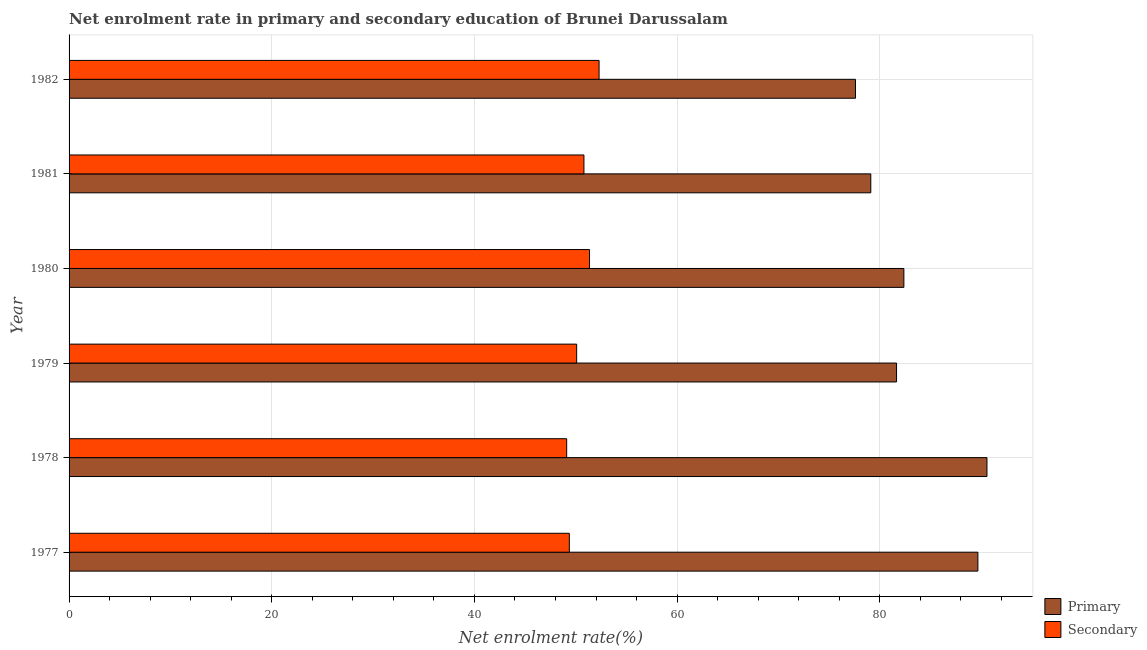How many different coloured bars are there?
Give a very brief answer. 2. How many bars are there on the 2nd tick from the top?
Offer a very short reply. 2. What is the enrollment rate in primary education in 1981?
Your answer should be very brief. 79.11. Across all years, what is the maximum enrollment rate in secondary education?
Your answer should be compact. 52.3. Across all years, what is the minimum enrollment rate in primary education?
Ensure brevity in your answer.  77.6. In which year was the enrollment rate in secondary education maximum?
Offer a very short reply. 1982. What is the total enrollment rate in secondary education in the graph?
Keep it short and to the point. 303.01. What is the difference between the enrollment rate in secondary education in 1979 and that in 1980?
Offer a terse response. -1.27. What is the difference between the enrollment rate in secondary education in 1982 and the enrollment rate in primary education in 1981?
Give a very brief answer. -26.81. What is the average enrollment rate in primary education per year?
Your answer should be very brief. 83.5. In the year 1979, what is the difference between the enrollment rate in secondary education and enrollment rate in primary education?
Give a very brief answer. -31.57. In how many years, is the enrollment rate in primary education greater than 76 %?
Offer a terse response. 6. What is the ratio of the enrollment rate in primary education in 1978 to that in 1982?
Your answer should be compact. 1.17. Is the enrollment rate in secondary education in 1977 less than that in 1981?
Make the answer very short. Yes. What is the difference between the highest and the second highest enrollment rate in primary education?
Offer a terse response. 0.9. What is the difference between the highest and the lowest enrollment rate in primary education?
Offer a terse response. 12.97. In how many years, is the enrollment rate in secondary education greater than the average enrollment rate in secondary education taken over all years?
Provide a short and direct response. 3. Is the sum of the enrollment rate in primary education in 1977 and 1980 greater than the maximum enrollment rate in secondary education across all years?
Keep it short and to the point. Yes. What does the 1st bar from the top in 1981 represents?
Keep it short and to the point. Secondary. What does the 2nd bar from the bottom in 1981 represents?
Keep it short and to the point. Secondary. How many years are there in the graph?
Ensure brevity in your answer.  6. What is the difference between two consecutive major ticks on the X-axis?
Provide a short and direct response. 20. Are the values on the major ticks of X-axis written in scientific E-notation?
Offer a very short reply. No. Does the graph contain any zero values?
Your answer should be compact. No. Where does the legend appear in the graph?
Provide a short and direct response. Bottom right. How many legend labels are there?
Provide a succinct answer. 2. How are the legend labels stacked?
Provide a short and direct response. Vertical. What is the title of the graph?
Provide a succinct answer. Net enrolment rate in primary and secondary education of Brunei Darussalam. Does "RDB concessional" appear as one of the legend labels in the graph?
Provide a short and direct response. No. What is the label or title of the X-axis?
Ensure brevity in your answer.  Net enrolment rate(%). What is the Net enrolment rate(%) in Primary in 1977?
Make the answer very short. 89.68. What is the Net enrolment rate(%) in Secondary in 1977?
Keep it short and to the point. 49.36. What is the Net enrolment rate(%) in Primary in 1978?
Keep it short and to the point. 90.57. What is the Net enrolment rate(%) of Secondary in 1978?
Provide a short and direct response. 49.1. What is the Net enrolment rate(%) of Primary in 1979?
Give a very brief answer. 81.65. What is the Net enrolment rate(%) of Secondary in 1979?
Keep it short and to the point. 50.09. What is the Net enrolment rate(%) of Primary in 1980?
Keep it short and to the point. 82.38. What is the Net enrolment rate(%) of Secondary in 1980?
Keep it short and to the point. 51.36. What is the Net enrolment rate(%) of Primary in 1981?
Provide a short and direct response. 79.11. What is the Net enrolment rate(%) in Secondary in 1981?
Give a very brief answer. 50.8. What is the Net enrolment rate(%) of Primary in 1982?
Ensure brevity in your answer.  77.6. What is the Net enrolment rate(%) of Secondary in 1982?
Your response must be concise. 52.3. Across all years, what is the maximum Net enrolment rate(%) in Primary?
Ensure brevity in your answer.  90.57. Across all years, what is the maximum Net enrolment rate(%) of Secondary?
Give a very brief answer. 52.3. Across all years, what is the minimum Net enrolment rate(%) in Primary?
Offer a terse response. 77.6. Across all years, what is the minimum Net enrolment rate(%) in Secondary?
Offer a very short reply. 49.1. What is the total Net enrolment rate(%) of Primary in the graph?
Provide a succinct answer. 500.99. What is the total Net enrolment rate(%) in Secondary in the graph?
Your response must be concise. 303.01. What is the difference between the Net enrolment rate(%) of Primary in 1977 and that in 1978?
Make the answer very short. -0.9. What is the difference between the Net enrolment rate(%) in Secondary in 1977 and that in 1978?
Offer a terse response. 0.26. What is the difference between the Net enrolment rate(%) in Primary in 1977 and that in 1979?
Provide a succinct answer. 8.03. What is the difference between the Net enrolment rate(%) in Secondary in 1977 and that in 1979?
Offer a terse response. -0.72. What is the difference between the Net enrolment rate(%) in Primary in 1977 and that in 1980?
Give a very brief answer. 7.3. What is the difference between the Net enrolment rate(%) in Secondary in 1977 and that in 1980?
Your response must be concise. -1.99. What is the difference between the Net enrolment rate(%) of Primary in 1977 and that in 1981?
Make the answer very short. 10.57. What is the difference between the Net enrolment rate(%) of Secondary in 1977 and that in 1981?
Ensure brevity in your answer.  -1.44. What is the difference between the Net enrolment rate(%) of Primary in 1977 and that in 1982?
Make the answer very short. 12.08. What is the difference between the Net enrolment rate(%) of Secondary in 1977 and that in 1982?
Offer a terse response. -2.94. What is the difference between the Net enrolment rate(%) in Primary in 1978 and that in 1979?
Make the answer very short. 8.92. What is the difference between the Net enrolment rate(%) in Secondary in 1978 and that in 1979?
Keep it short and to the point. -0.98. What is the difference between the Net enrolment rate(%) of Primary in 1978 and that in 1980?
Make the answer very short. 8.2. What is the difference between the Net enrolment rate(%) of Secondary in 1978 and that in 1980?
Give a very brief answer. -2.25. What is the difference between the Net enrolment rate(%) of Primary in 1978 and that in 1981?
Provide a succinct answer. 11.46. What is the difference between the Net enrolment rate(%) in Secondary in 1978 and that in 1981?
Give a very brief answer. -1.7. What is the difference between the Net enrolment rate(%) of Primary in 1978 and that in 1982?
Your answer should be compact. 12.97. What is the difference between the Net enrolment rate(%) in Secondary in 1978 and that in 1982?
Offer a terse response. -3.2. What is the difference between the Net enrolment rate(%) of Primary in 1979 and that in 1980?
Your answer should be very brief. -0.72. What is the difference between the Net enrolment rate(%) of Secondary in 1979 and that in 1980?
Give a very brief answer. -1.27. What is the difference between the Net enrolment rate(%) of Primary in 1979 and that in 1981?
Ensure brevity in your answer.  2.54. What is the difference between the Net enrolment rate(%) in Secondary in 1979 and that in 1981?
Provide a succinct answer. -0.72. What is the difference between the Net enrolment rate(%) of Primary in 1979 and that in 1982?
Your response must be concise. 4.05. What is the difference between the Net enrolment rate(%) of Secondary in 1979 and that in 1982?
Provide a short and direct response. -2.21. What is the difference between the Net enrolment rate(%) in Primary in 1980 and that in 1981?
Your answer should be compact. 3.26. What is the difference between the Net enrolment rate(%) of Secondary in 1980 and that in 1981?
Offer a terse response. 0.55. What is the difference between the Net enrolment rate(%) in Primary in 1980 and that in 1982?
Your response must be concise. 4.78. What is the difference between the Net enrolment rate(%) in Secondary in 1980 and that in 1982?
Your response must be concise. -0.94. What is the difference between the Net enrolment rate(%) in Primary in 1981 and that in 1982?
Keep it short and to the point. 1.51. What is the difference between the Net enrolment rate(%) of Secondary in 1981 and that in 1982?
Give a very brief answer. -1.5. What is the difference between the Net enrolment rate(%) in Primary in 1977 and the Net enrolment rate(%) in Secondary in 1978?
Offer a very short reply. 40.58. What is the difference between the Net enrolment rate(%) in Primary in 1977 and the Net enrolment rate(%) in Secondary in 1979?
Your answer should be compact. 39.59. What is the difference between the Net enrolment rate(%) of Primary in 1977 and the Net enrolment rate(%) of Secondary in 1980?
Ensure brevity in your answer.  38.32. What is the difference between the Net enrolment rate(%) of Primary in 1977 and the Net enrolment rate(%) of Secondary in 1981?
Provide a short and direct response. 38.88. What is the difference between the Net enrolment rate(%) of Primary in 1977 and the Net enrolment rate(%) of Secondary in 1982?
Give a very brief answer. 37.38. What is the difference between the Net enrolment rate(%) in Primary in 1978 and the Net enrolment rate(%) in Secondary in 1979?
Keep it short and to the point. 40.49. What is the difference between the Net enrolment rate(%) of Primary in 1978 and the Net enrolment rate(%) of Secondary in 1980?
Ensure brevity in your answer.  39.22. What is the difference between the Net enrolment rate(%) of Primary in 1978 and the Net enrolment rate(%) of Secondary in 1981?
Ensure brevity in your answer.  39.77. What is the difference between the Net enrolment rate(%) in Primary in 1978 and the Net enrolment rate(%) in Secondary in 1982?
Keep it short and to the point. 38.28. What is the difference between the Net enrolment rate(%) in Primary in 1979 and the Net enrolment rate(%) in Secondary in 1980?
Offer a very short reply. 30.3. What is the difference between the Net enrolment rate(%) in Primary in 1979 and the Net enrolment rate(%) in Secondary in 1981?
Ensure brevity in your answer.  30.85. What is the difference between the Net enrolment rate(%) in Primary in 1979 and the Net enrolment rate(%) in Secondary in 1982?
Offer a terse response. 29.35. What is the difference between the Net enrolment rate(%) in Primary in 1980 and the Net enrolment rate(%) in Secondary in 1981?
Give a very brief answer. 31.57. What is the difference between the Net enrolment rate(%) in Primary in 1980 and the Net enrolment rate(%) in Secondary in 1982?
Make the answer very short. 30.08. What is the difference between the Net enrolment rate(%) of Primary in 1981 and the Net enrolment rate(%) of Secondary in 1982?
Your answer should be compact. 26.81. What is the average Net enrolment rate(%) of Primary per year?
Make the answer very short. 83.5. What is the average Net enrolment rate(%) in Secondary per year?
Make the answer very short. 50.5. In the year 1977, what is the difference between the Net enrolment rate(%) in Primary and Net enrolment rate(%) in Secondary?
Offer a very short reply. 40.32. In the year 1978, what is the difference between the Net enrolment rate(%) of Primary and Net enrolment rate(%) of Secondary?
Your response must be concise. 41.47. In the year 1979, what is the difference between the Net enrolment rate(%) of Primary and Net enrolment rate(%) of Secondary?
Make the answer very short. 31.57. In the year 1980, what is the difference between the Net enrolment rate(%) in Primary and Net enrolment rate(%) in Secondary?
Provide a short and direct response. 31.02. In the year 1981, what is the difference between the Net enrolment rate(%) in Primary and Net enrolment rate(%) in Secondary?
Your answer should be very brief. 28.31. In the year 1982, what is the difference between the Net enrolment rate(%) in Primary and Net enrolment rate(%) in Secondary?
Your answer should be very brief. 25.3. What is the ratio of the Net enrolment rate(%) in Primary in 1977 to that in 1978?
Make the answer very short. 0.99. What is the ratio of the Net enrolment rate(%) in Secondary in 1977 to that in 1978?
Ensure brevity in your answer.  1.01. What is the ratio of the Net enrolment rate(%) of Primary in 1977 to that in 1979?
Keep it short and to the point. 1.1. What is the ratio of the Net enrolment rate(%) of Secondary in 1977 to that in 1979?
Keep it short and to the point. 0.99. What is the ratio of the Net enrolment rate(%) of Primary in 1977 to that in 1980?
Provide a short and direct response. 1.09. What is the ratio of the Net enrolment rate(%) of Secondary in 1977 to that in 1980?
Provide a succinct answer. 0.96. What is the ratio of the Net enrolment rate(%) in Primary in 1977 to that in 1981?
Your response must be concise. 1.13. What is the ratio of the Net enrolment rate(%) of Secondary in 1977 to that in 1981?
Provide a short and direct response. 0.97. What is the ratio of the Net enrolment rate(%) in Primary in 1977 to that in 1982?
Make the answer very short. 1.16. What is the ratio of the Net enrolment rate(%) of Secondary in 1977 to that in 1982?
Offer a very short reply. 0.94. What is the ratio of the Net enrolment rate(%) of Primary in 1978 to that in 1979?
Your response must be concise. 1.11. What is the ratio of the Net enrolment rate(%) of Secondary in 1978 to that in 1979?
Your answer should be compact. 0.98. What is the ratio of the Net enrolment rate(%) of Primary in 1978 to that in 1980?
Your response must be concise. 1.1. What is the ratio of the Net enrolment rate(%) in Secondary in 1978 to that in 1980?
Make the answer very short. 0.96. What is the ratio of the Net enrolment rate(%) of Primary in 1978 to that in 1981?
Your answer should be compact. 1.14. What is the ratio of the Net enrolment rate(%) of Secondary in 1978 to that in 1981?
Offer a terse response. 0.97. What is the ratio of the Net enrolment rate(%) of Primary in 1978 to that in 1982?
Give a very brief answer. 1.17. What is the ratio of the Net enrolment rate(%) in Secondary in 1978 to that in 1982?
Offer a terse response. 0.94. What is the ratio of the Net enrolment rate(%) of Primary in 1979 to that in 1980?
Ensure brevity in your answer.  0.99. What is the ratio of the Net enrolment rate(%) in Secondary in 1979 to that in 1980?
Offer a very short reply. 0.98. What is the ratio of the Net enrolment rate(%) of Primary in 1979 to that in 1981?
Give a very brief answer. 1.03. What is the ratio of the Net enrolment rate(%) in Secondary in 1979 to that in 1981?
Make the answer very short. 0.99. What is the ratio of the Net enrolment rate(%) of Primary in 1979 to that in 1982?
Give a very brief answer. 1.05. What is the ratio of the Net enrolment rate(%) in Secondary in 1979 to that in 1982?
Provide a short and direct response. 0.96. What is the ratio of the Net enrolment rate(%) in Primary in 1980 to that in 1981?
Your response must be concise. 1.04. What is the ratio of the Net enrolment rate(%) in Secondary in 1980 to that in 1981?
Offer a terse response. 1.01. What is the ratio of the Net enrolment rate(%) of Primary in 1980 to that in 1982?
Ensure brevity in your answer.  1.06. What is the ratio of the Net enrolment rate(%) of Secondary in 1980 to that in 1982?
Your answer should be compact. 0.98. What is the ratio of the Net enrolment rate(%) in Primary in 1981 to that in 1982?
Offer a very short reply. 1.02. What is the ratio of the Net enrolment rate(%) in Secondary in 1981 to that in 1982?
Your answer should be very brief. 0.97. What is the difference between the highest and the second highest Net enrolment rate(%) of Primary?
Offer a terse response. 0.9. What is the difference between the highest and the second highest Net enrolment rate(%) of Secondary?
Make the answer very short. 0.94. What is the difference between the highest and the lowest Net enrolment rate(%) in Primary?
Offer a terse response. 12.97. What is the difference between the highest and the lowest Net enrolment rate(%) in Secondary?
Give a very brief answer. 3.2. 